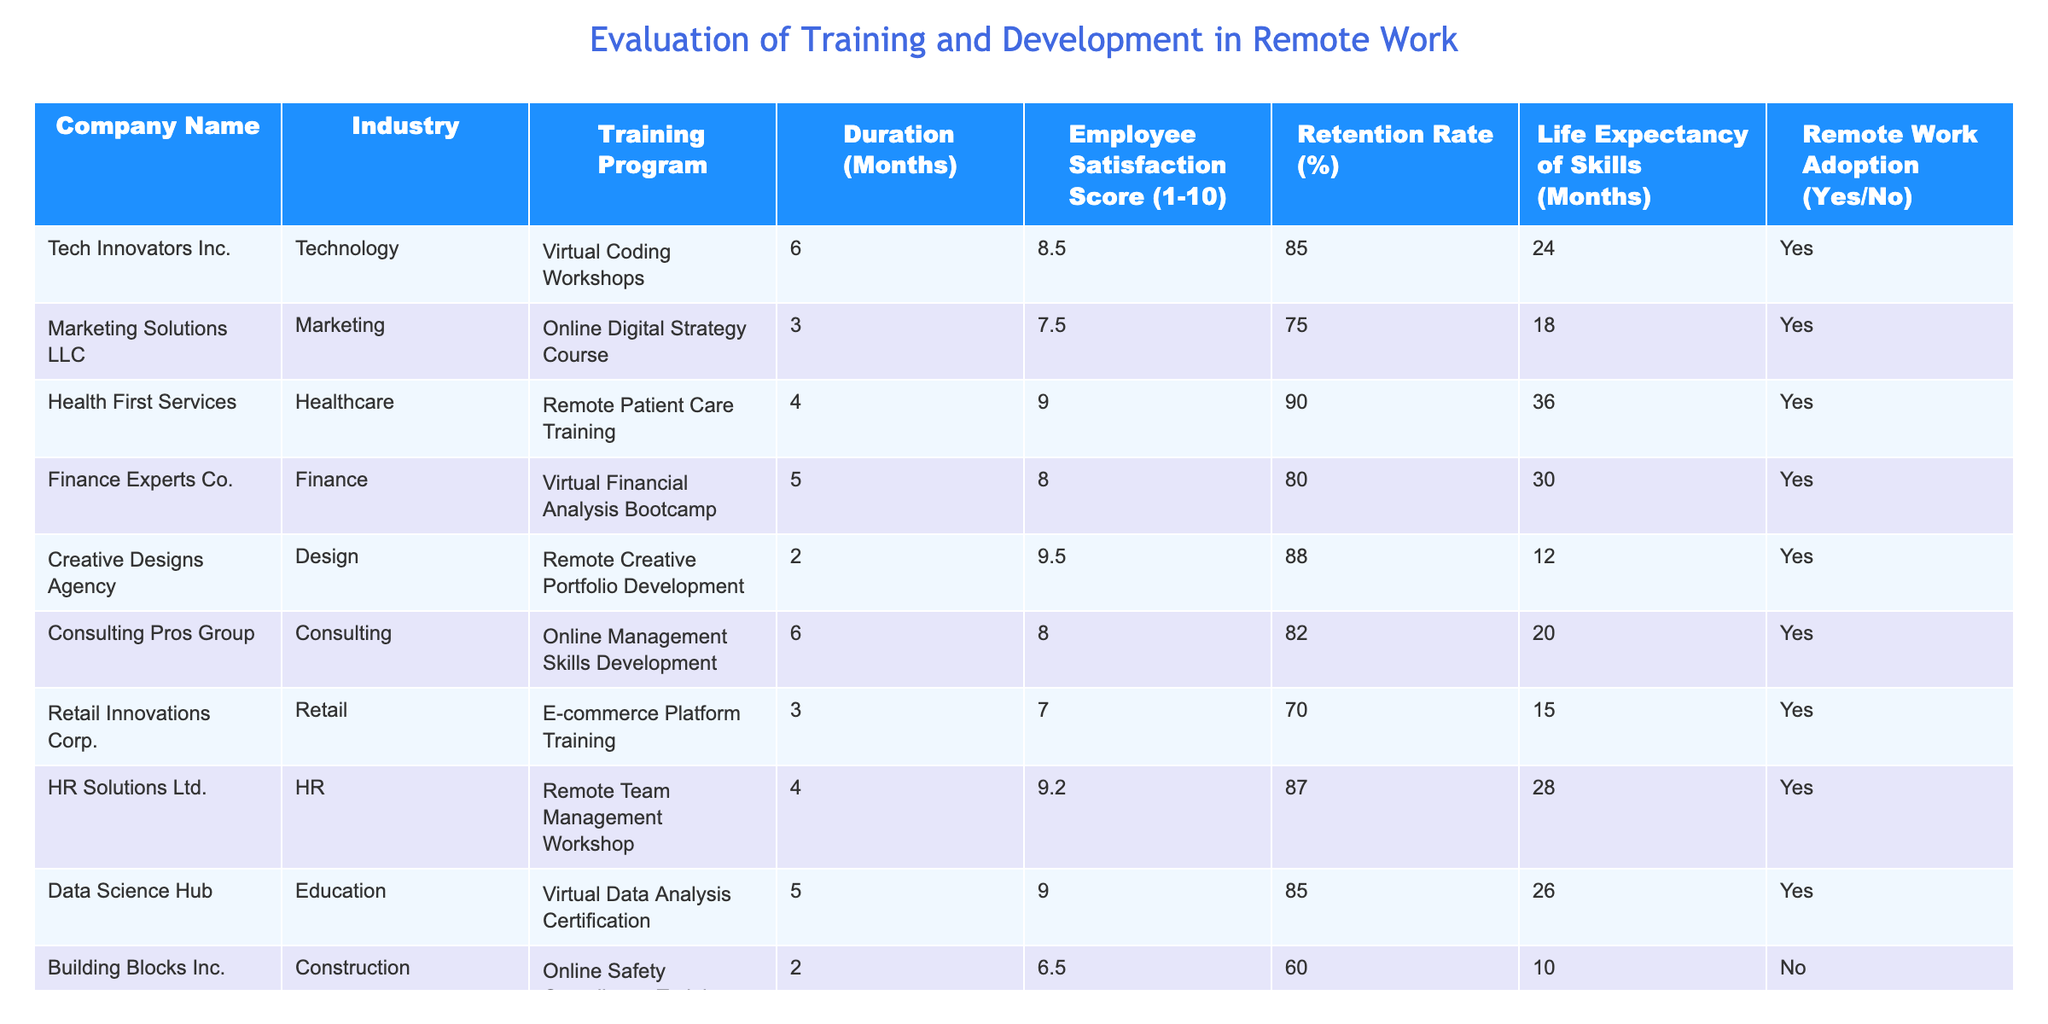What is the Employee Satisfaction Score for Health First Services? The table lists the Employee Satisfaction Score under the "Employee Satisfaction Score (1-10)" column for each company. For Health First Services, the score is clearly stated as 9.0.
Answer: 9.0 What is the Retention Rate of Creative Designs Agency? Referring to the "Retention Rate (%)" column in the table, the rate for Creative Designs Agency is given as 88%.
Answer: 88% Which training program has the longest Life Expectancy of Skills? By looking at the "Life Expectancy of Skills (Months)" column, we can see that Remote Patient Care Training from Health First Services has the highest value at 36 months.
Answer: 36 months What is the average Duration of the training programs for companies that have adopted remote work? The relevant training programs with remote work adoption are Virtual Coding Workshops (6 months), Online Digital Strategy Course (3 months), Remote Patient Care Training (4 months), Virtual Financial Analysis Bootcamp (5 months), Remote Creative Portfolio Development (2 months), Online Management Skills Development (6 months), E-commerce Platform Training (3 months), Remote Team Management Workshop (4 months), and Virtual Data Analysis Certification (5 months). Adding these durations gives a total of 44 months, and there are 9 training programs, leading to an average of 44/9 which equals approximately 4.89 months.
Answer: 4.89 months Is there a training program with both high Employee Satisfaction Score and high Retention Rate that also adopts remote work? By examining the table, the program "Remote Patient Care Training" has an Employee Satisfaction Score of 9.0 and a Retention Rate of 90%. Thus, it satisfies both criteria and also indicates an adoption of remote work.
Answer: Yes What is the difference in Retention Rate between the highest and lowest scoring companies in the table? The highest Retention Rate is 90% from Health First Services, and the lowest Retention Rate is 60% from Building Blocks Inc. Calculating the difference, 90 - 60 gives us 30%.
Answer: 30% How many companies have a life expectancy of skills greater than 20 months and who offer remote work training? Filtering the table, we identify the companies with a Life Expectancy of Skills greater than 20 months. These are Health First Services (36 months), Finance Experts Co. (30 months), HR Solutions Ltd. (28 months), and Data Science Hub (26 months). Thus, there are 4 companies.
Answer: 4 companies What percentage of training programs are from the Technology industry and offer remote work opportunities? In the table, there's only one company from the Technology industry with a remote work training program, which is Tech Innovators Inc. There are a total of 9 training programs with remote work adoption. Thus, the percentage is (1/9) * 100 = approximately 11.11%.
Answer: 11.11% What is the most common industry among companies that have adopted remote work? By reviewing the "Industry" column for companies that have remote work adoption, we find Technology, Marketing, Healthcare, Finance, Design, Consulting, Retail, HR, and Education. The industry with the highest frequency is "Yes" for all listed, but counts show many diverse industries with no repeats.
Answer: No common industry 